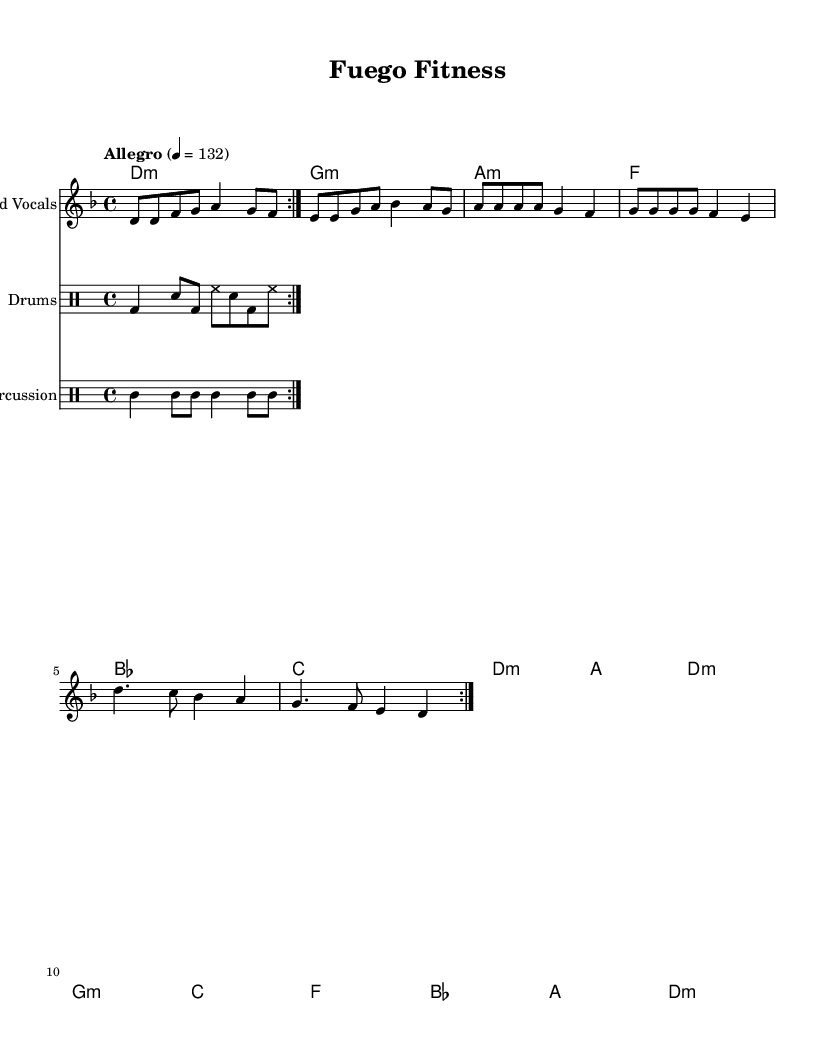What is the key signature of this music? The key signature is D minor, which has one flat (B flat). It is indicated at the beginning of the staff with the flat sign.
Answer: D minor What is the time signature of this music? The time signature appears at the beginning of the staff and is represented by the "4/4" notation, indicating four beats in a measure and that the quarter note gets one beat.
Answer: 4/4 What is the tempo marking for this piece? The tempo marking at the beginning of the piece is marked as "Allegro" with a metronome indication of 132. "Allegro" signifies a fast and lively pace.
Answer: Allegro 4 = 132 How many measures are in the repeated section of the melody? The repeated section of the melody is specified to repeat volta 2, indicating that the two measures will be played twice, making a total of eight measures in the repeated section.
Answer: 8 measures What instruments are present in this score? The score includes parts for "Lead Vocals," "Drums," and "Percussion." Each instrument has its designated staff shown at the beginning.
Answer: Lead Vocals, Drums, Percussion What is the purpose of the lyrics in this piece? The lyrics serve to enhance the theme of physical fitness and movement, matching the energetic style of the music and motivating the listeners during workouts.
Answer: Motivational How does the chord progression contribute to the Latin feel of the music? The chord progression features minor chords (D minor, G minor, A minor), which evoke a characteristic Latin flavor, while the rhythm and structure contribute to its energetic dance quality.
Answer: Latin flavor 